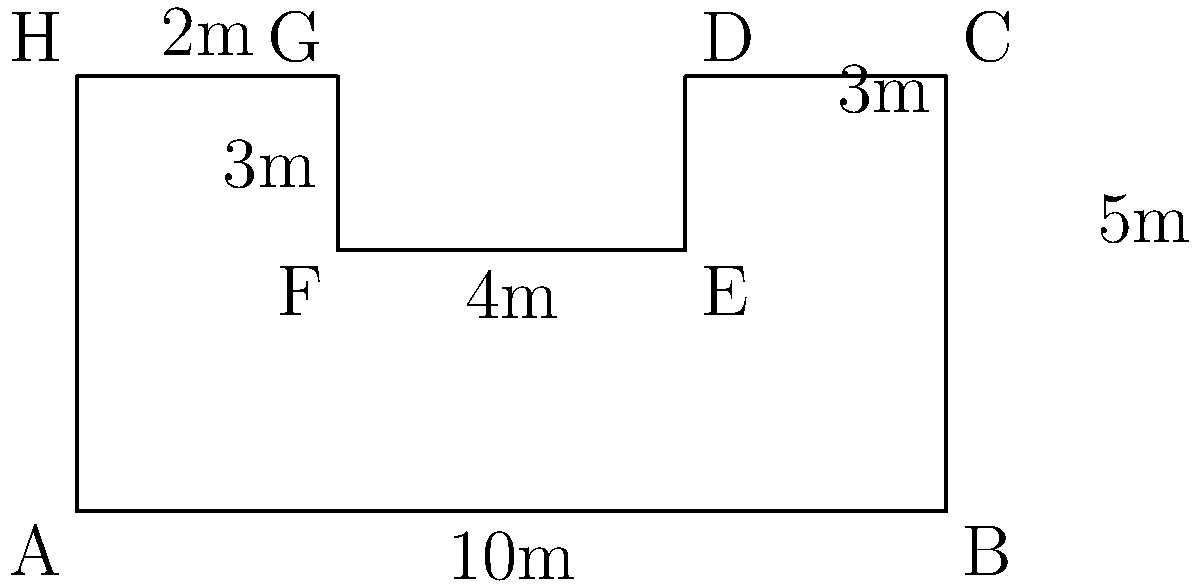As an entrepreneur with experience in office space planning, you're tasked with calculating the perimeter of an irregularly shaped office floor plan. The floor plan is represented by the diagram above, where each small square represents 1 square meter. What is the total perimeter of this office space in meters? To calculate the perimeter, we need to sum up the lengths of all sides of the office floor plan. Let's break it down step by step:

1. Bottom side (AB): 10m
2. Right side (BC): 5m
3. Top-right segment (CD): 3m
4. Right indent (DE): 2m
5. Top-middle segment (EF): 4m
6. Left indent (FG): 2m
7. Top-left segment (GH): 3m
8. Left side (HA): 5m

Now, let's add all these lengths:

$$\text{Perimeter} = 10 + 5 + 3 + 2 + 4 + 2 + 3 + 5 = 34\text{ meters}$$

Therefore, the total perimeter of the office space is 34 meters.
Answer: 34 meters 